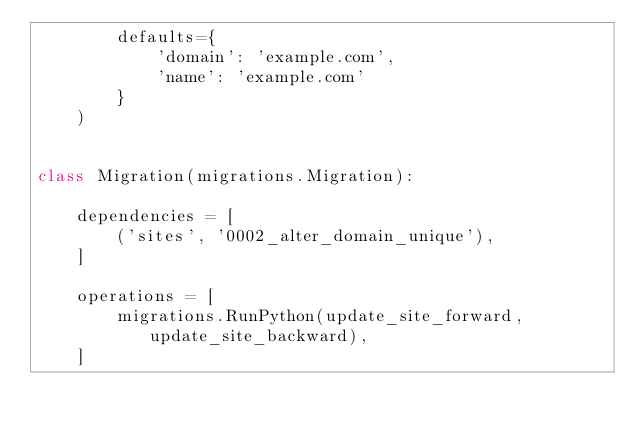Convert code to text. <code><loc_0><loc_0><loc_500><loc_500><_Python_>        defaults={
            'domain': 'example.com',
            'name': 'example.com'
        }
    )


class Migration(migrations.Migration):

    dependencies = [
        ('sites', '0002_alter_domain_unique'),
    ]

    operations = [
        migrations.RunPython(update_site_forward, update_site_backward),
    ]
</code> 